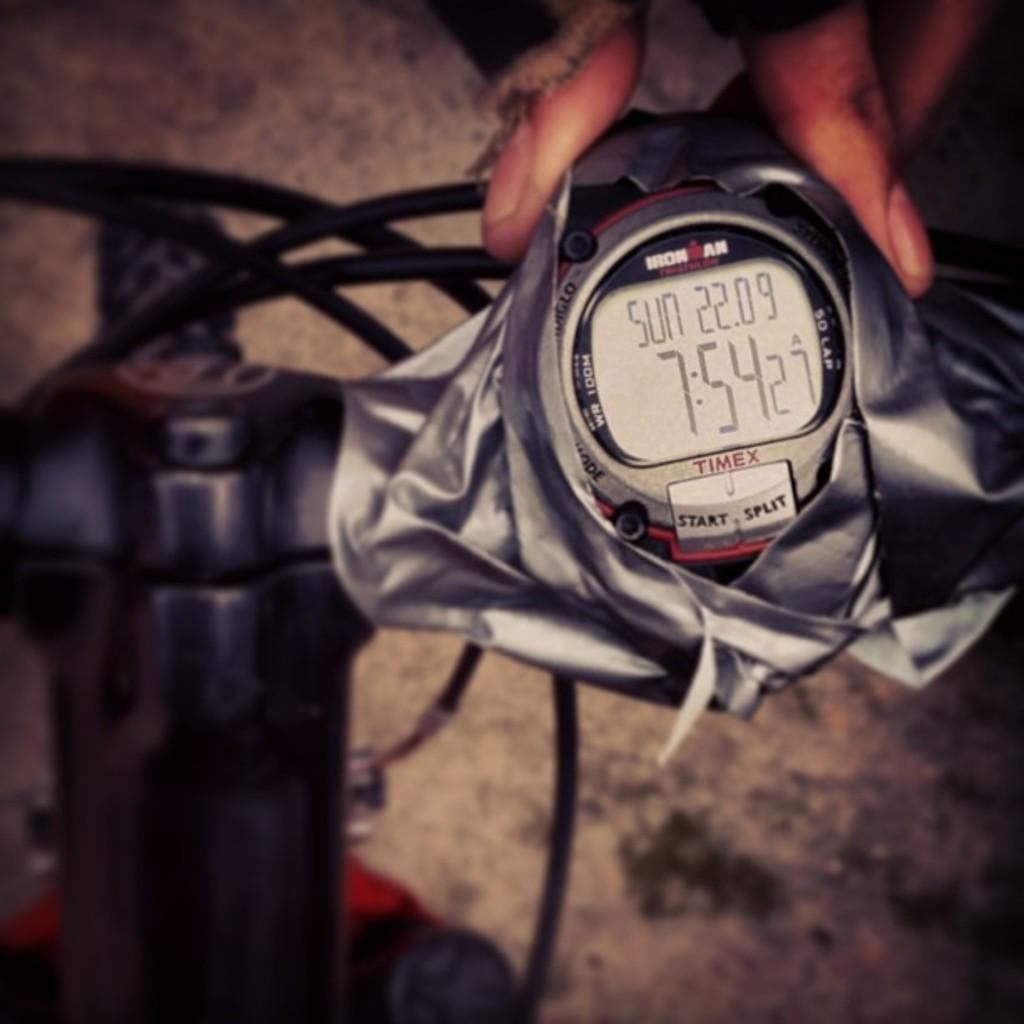<image>
Give a short and clear explanation of the subsequent image. A watch with the time of 7:54 on it 